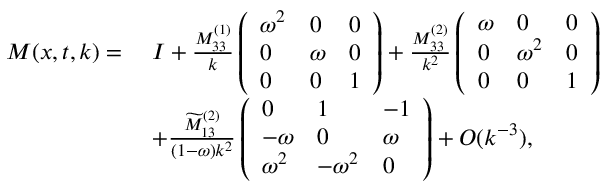Convert formula to latex. <formula><loc_0><loc_0><loc_500><loc_500>\begin{array} { r l } { M ( x , t , k ) = } & { \, I + \frac { M _ { 3 3 } ^ { ( 1 ) } } { k } \left ( \begin{array} { l l l } { \omega ^ { 2 } } & { 0 } & { 0 } \\ { 0 } & { \omega } & { 0 } \\ { 0 } & { 0 } & { 1 } \end{array} \right ) + \frac { M _ { 3 3 } ^ { ( 2 ) } } { k ^ { 2 } } \left ( \begin{array} { l l l } { \omega } & { 0 } & { 0 } \\ { 0 } & { \omega ^ { 2 } } & { 0 } \\ { 0 } & { 0 } & { 1 } \end{array} \right ) } \\ & { \, + \frac { \widetilde { M } _ { 1 3 } ^ { ( 2 ) } } { ( 1 - \omega ) k ^ { 2 } } \left ( \begin{array} { l l l } { 0 } & { 1 } & { - 1 } \\ { - \omega } & { 0 } & { \omega } \\ { \omega ^ { 2 } } & { - \omega ^ { 2 } } & { 0 } \end{array} \right ) + O ( k ^ { - 3 } ) , } \end{array}</formula> 